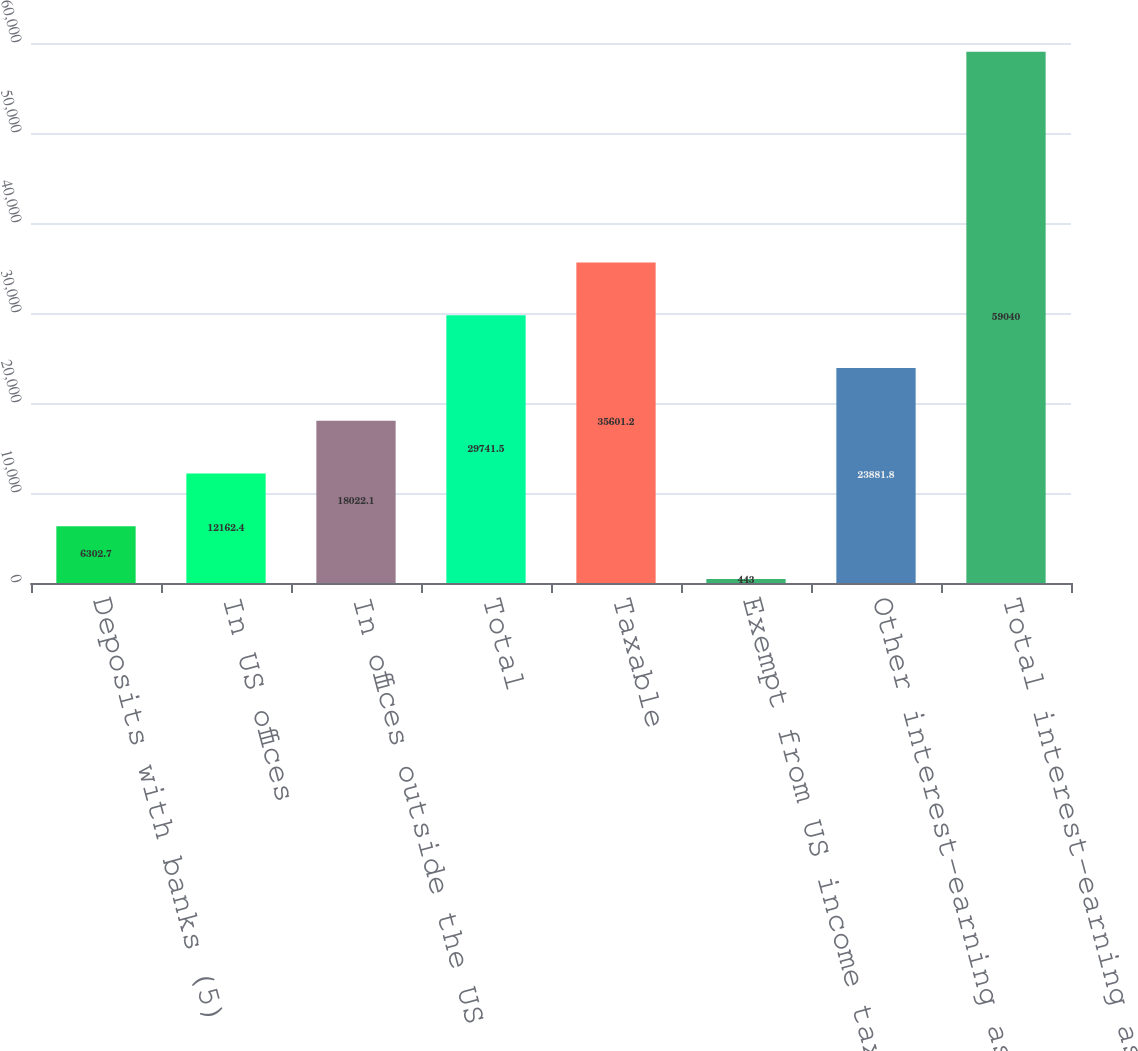<chart> <loc_0><loc_0><loc_500><loc_500><bar_chart><fcel>Deposits with banks (5)<fcel>In US offices<fcel>In offices outside the US (5)<fcel>Total<fcel>Taxable<fcel>Exempt from US income tax<fcel>Other interest-earning assets<fcel>Total interest-earning assets<nl><fcel>6302.7<fcel>12162.4<fcel>18022.1<fcel>29741.5<fcel>35601.2<fcel>443<fcel>23881.8<fcel>59040<nl></chart> 